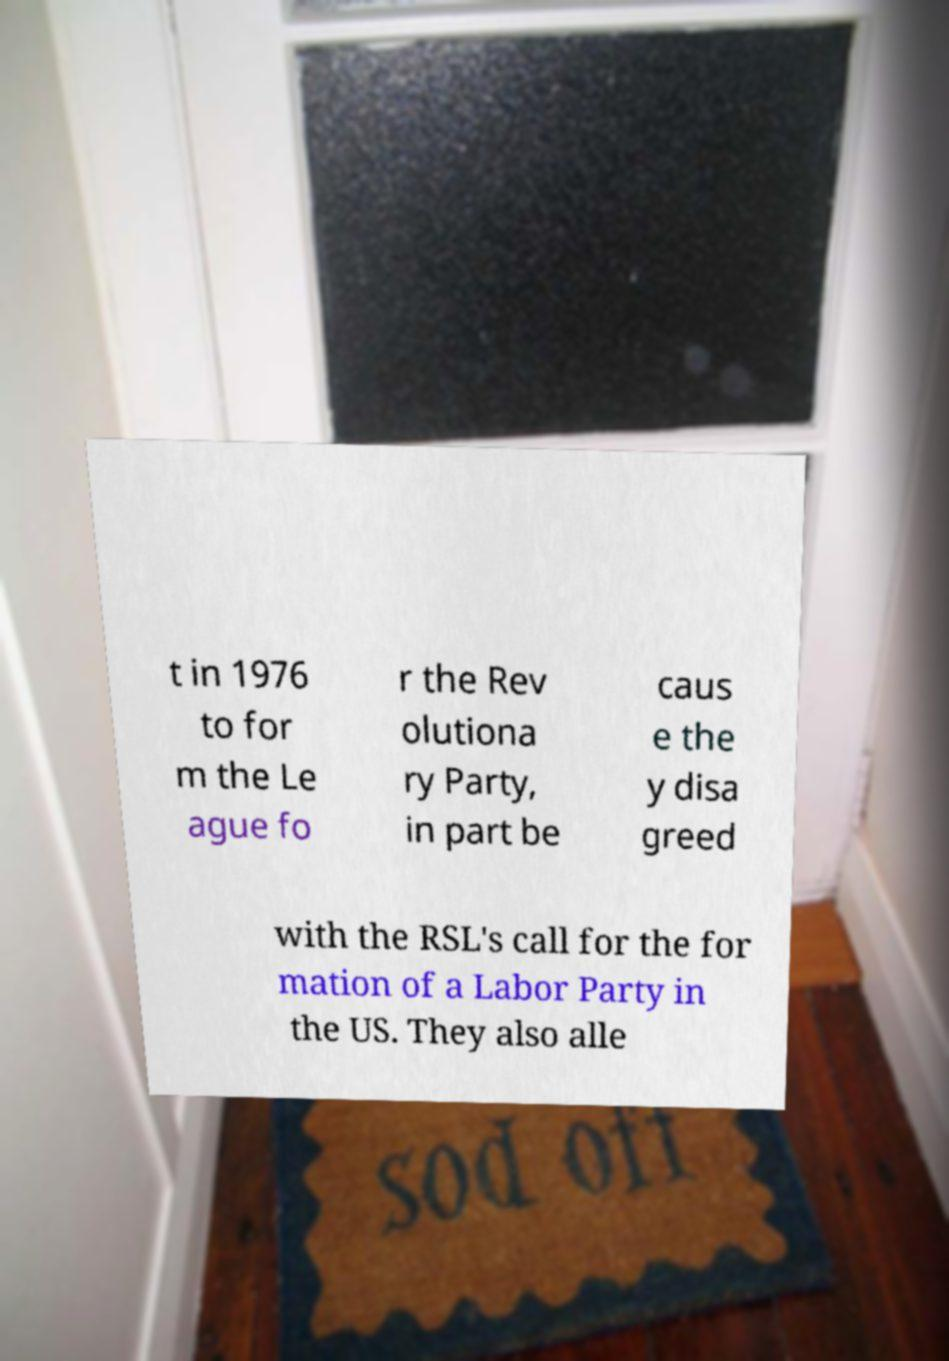What messages or text are displayed in this image? I need them in a readable, typed format. t in 1976 to for m the Le ague fo r the Rev olutiona ry Party, in part be caus e the y disa greed with the RSL's call for the for mation of a Labor Party in the US. They also alle 